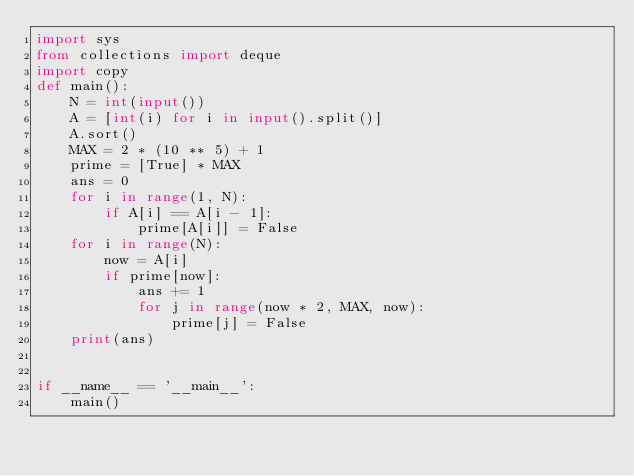<code> <loc_0><loc_0><loc_500><loc_500><_Python_>import sys
from collections import deque
import copy
def main():
    N = int(input())
    A = [int(i) for i in input().split()]
    A.sort()
    MAX = 2 * (10 ** 5) + 1
    prime = [True] * MAX
    ans = 0
    for i in range(1, N):
        if A[i] == A[i - 1]:
            prime[A[i]] = False
    for i in range(N):
        now = A[i]
        if prime[now]:
            ans += 1
            for j in range(now * 2, MAX, now):
                prime[j] = False
    print(ans)


if __name__ == '__main__':
    main()
</code> 